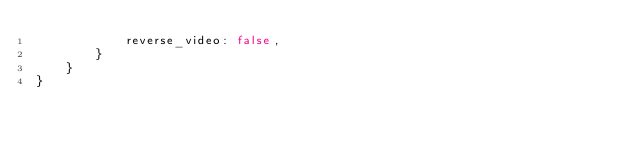Convert code to text. <code><loc_0><loc_0><loc_500><loc_500><_Rust_>            reverse_video: false,
        }
    }
}
</code> 